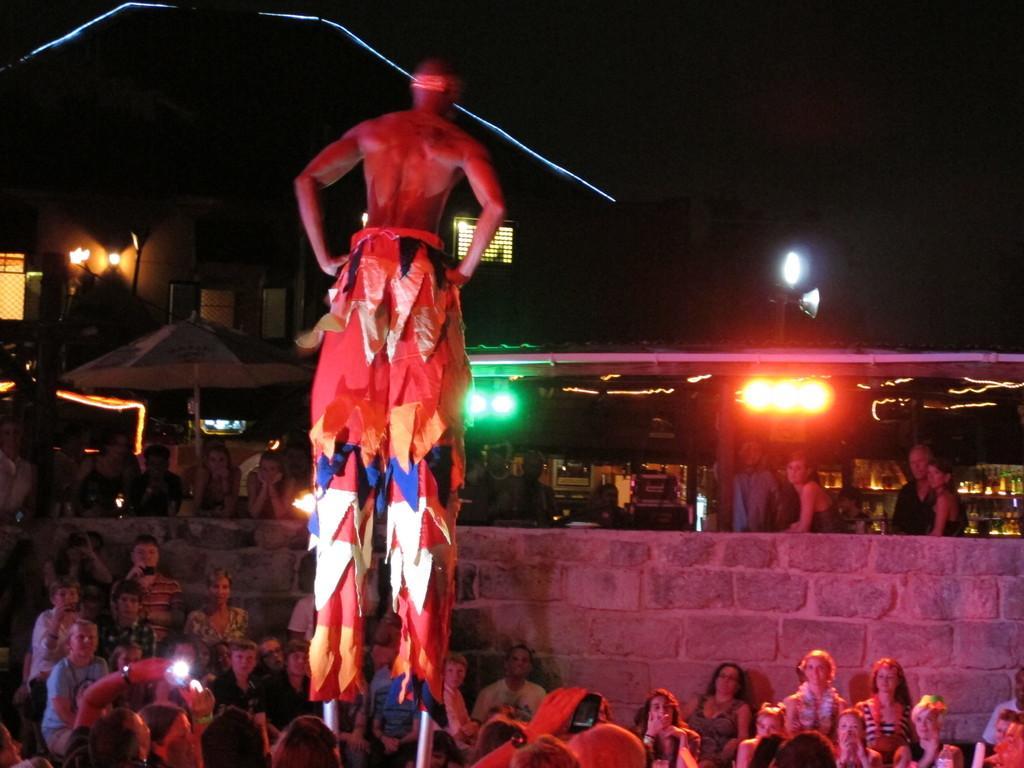In one or two sentences, can you explain what this image depicts? In this picture we can see a group of people, lights, buildings, umbrella and in the background it is dark. 